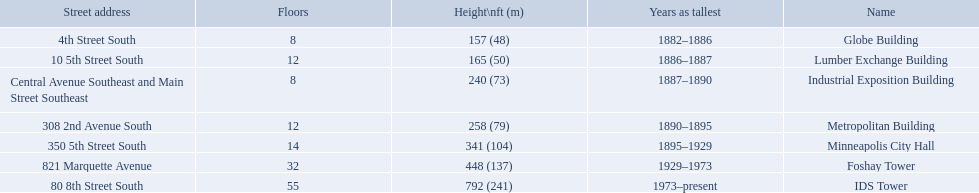How many floors does the lumber exchange building have? 12. What other building has 12 floors? Metropolitan Building. 